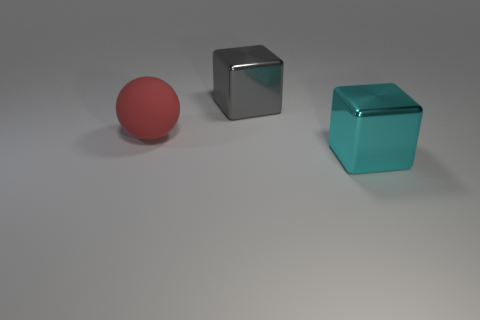Add 2 gray metal blocks. How many objects exist? 5 Subtract 1 cubes. How many cubes are left? 1 Subtract all tiny purple shiny cylinders. Subtract all large red spheres. How many objects are left? 2 Add 1 big cyan shiny objects. How many big cyan shiny objects are left? 2 Add 3 metallic objects. How many metallic objects exist? 5 Subtract 1 gray blocks. How many objects are left? 2 Subtract all balls. How many objects are left? 2 Subtract all green spheres. Subtract all brown cubes. How many spheres are left? 1 Subtract all cyan balls. How many blue cubes are left? 0 